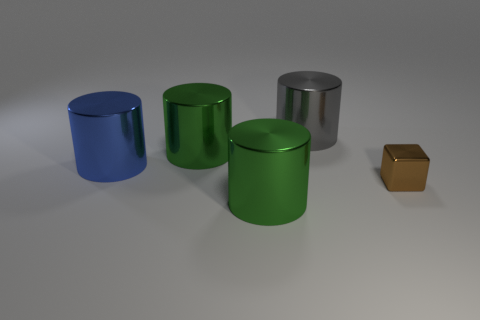Add 4 big gray cylinders. How many objects exist? 9 Subtract all large blue metallic cylinders. How many cylinders are left? 3 Subtract all yellow blocks. How many blue cylinders are left? 1 Subtract all large gray metallic things. Subtract all big gray things. How many objects are left? 3 Add 4 big green things. How many big green things are left? 6 Add 4 large yellow rubber cylinders. How many large yellow rubber cylinders exist? 4 Subtract all green cylinders. How many cylinders are left? 2 Subtract 0 purple cubes. How many objects are left? 5 Subtract all cylinders. How many objects are left? 1 Subtract 1 cylinders. How many cylinders are left? 3 